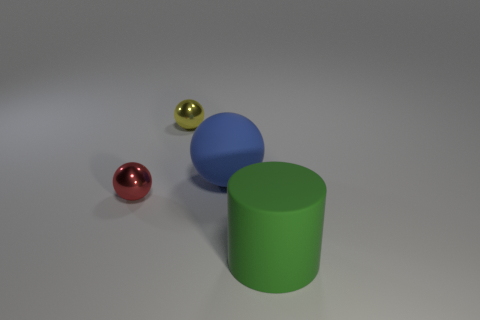Subtract all yellow shiny spheres. How many spheres are left? 2 Subtract all blue spheres. How many spheres are left? 2 Add 1 red things. How many objects exist? 5 Subtract all cylinders. How many objects are left? 3 Add 1 big spheres. How many big spheres are left? 2 Add 3 green cylinders. How many green cylinders exist? 4 Subtract 0 red cylinders. How many objects are left? 4 Subtract all cyan spheres. Subtract all brown cylinders. How many spheres are left? 3 Subtract all gray cubes. How many blue balls are left? 1 Subtract all tiny shiny objects. Subtract all big blue shiny blocks. How many objects are left? 2 